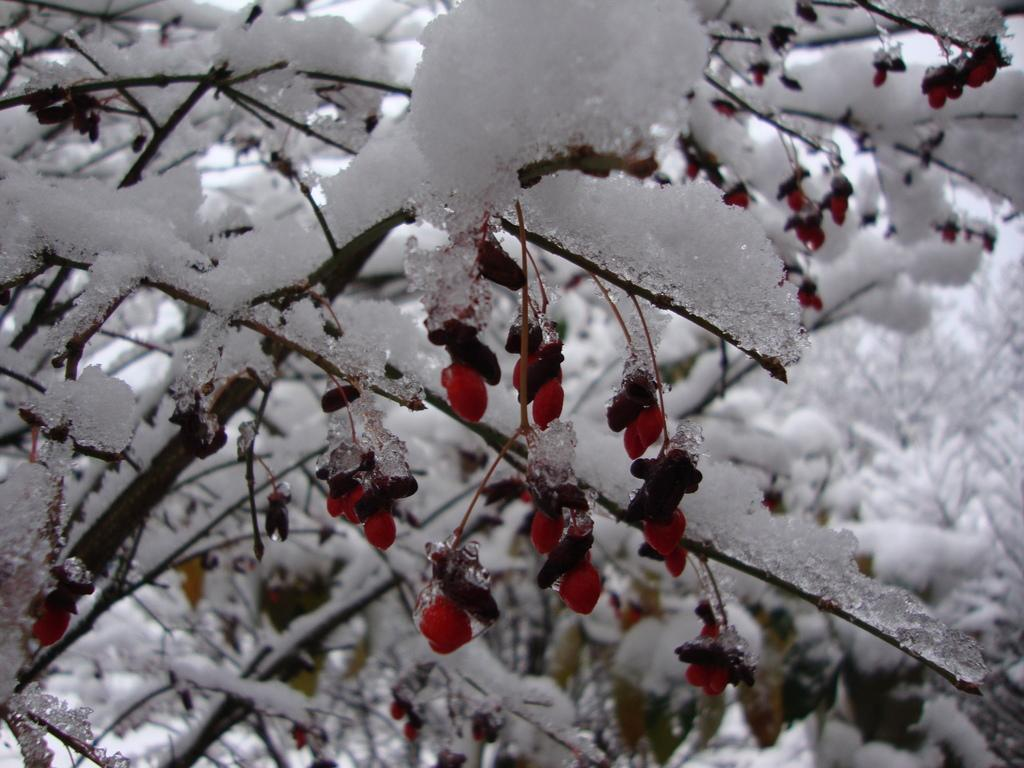What type of weather condition is depicted in the image? The image shows snow on the trees. How does the snow appear on the trees? The snow resembles fruits on the trees. What historical event is being commemorated in the image? There is no indication of a historical event in the image; it simply shows snow on trees. What type of vegetable is growing on the trees in the image? There are no vegetables, such as tomatoes, present in the image; it shows snow resembling fruits on the trees. 